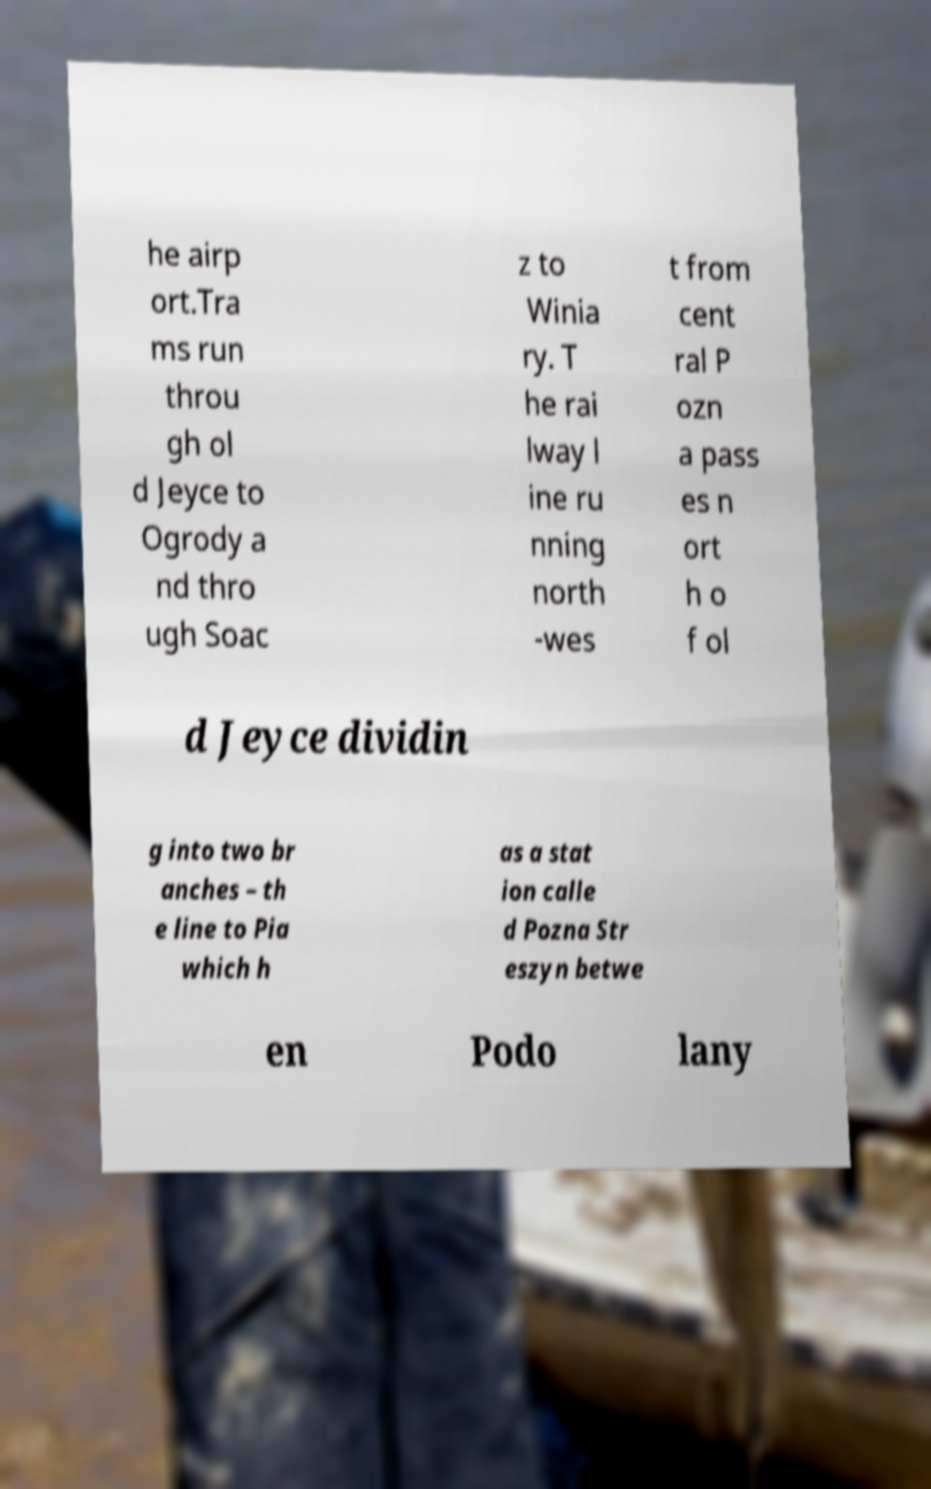Please read and relay the text visible in this image. What does it say? he airp ort.Tra ms run throu gh ol d Jeyce to Ogrody a nd thro ugh Soac z to Winia ry. T he rai lway l ine ru nning north -wes t from cent ral P ozn a pass es n ort h o f ol d Jeyce dividin g into two br anches – th e line to Pia which h as a stat ion calle d Pozna Str eszyn betwe en Podo lany 